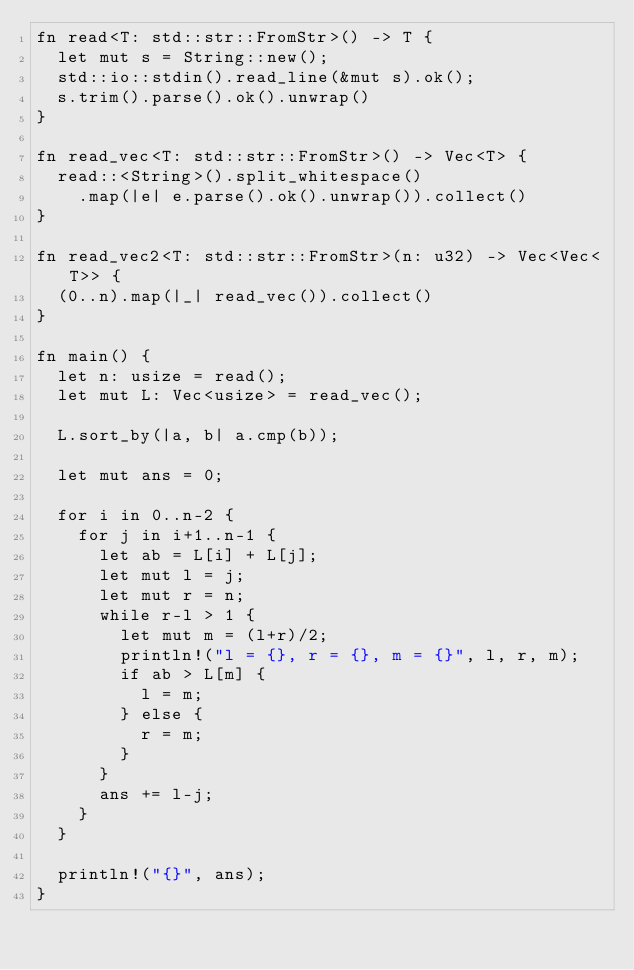Convert code to text. <code><loc_0><loc_0><loc_500><loc_500><_Rust_>fn read<T: std::str::FromStr>() -> T {
  let mut s = String::new();
  std::io::stdin().read_line(&mut s).ok();
  s.trim().parse().ok().unwrap()
}

fn read_vec<T: std::str::FromStr>() -> Vec<T> {
  read::<String>().split_whitespace()
    .map(|e| e.parse().ok().unwrap()).collect()
}

fn read_vec2<T: std::str::FromStr>(n: u32) -> Vec<Vec<T>> {
  (0..n).map(|_| read_vec()).collect()
}

fn main() {
  let n: usize = read();
  let mut L: Vec<usize> = read_vec();

  L.sort_by(|a, b| a.cmp(b));

  let mut ans = 0;

  for i in 0..n-2 {
    for j in i+1..n-1 {
      let ab = L[i] + L[j];
      let mut l = j;
      let mut r = n;
      while r-l > 1 {
        let mut m = (l+r)/2;
        println!("l = {}, r = {}, m = {}", l, r, m);
        if ab > L[m] {
          l = m;
        } else {
          r = m;
        }
      }
      ans += l-j;
    }
  }

  println!("{}", ans);
}</code> 